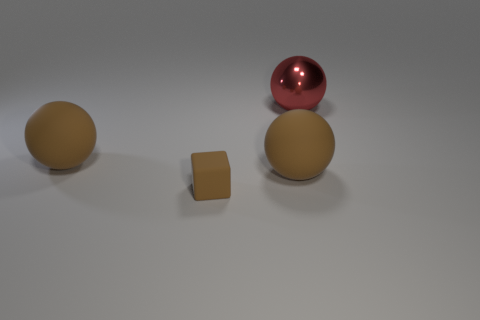Which objects in the image share the same color? The two larger spheres in the image share a similar shade of brown. 